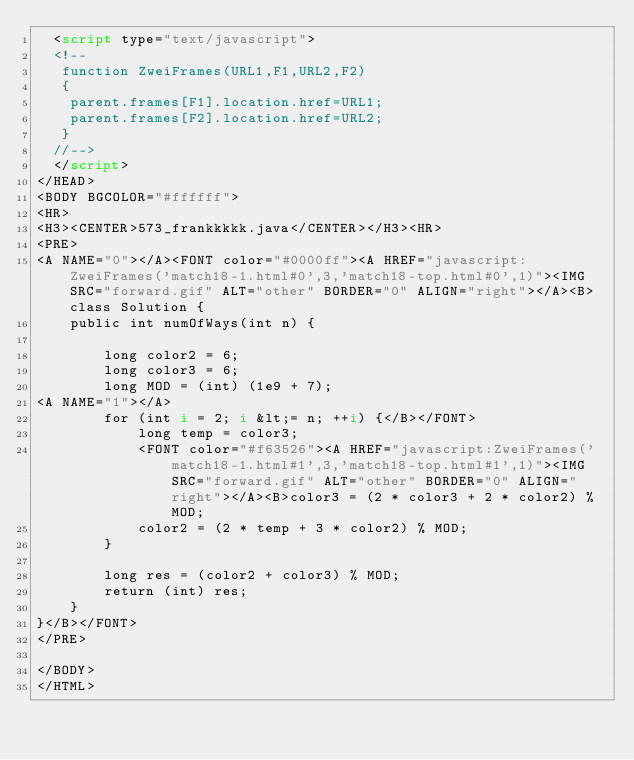<code> <loc_0><loc_0><loc_500><loc_500><_HTML_>  <script type="text/javascript">
  <!--
   function ZweiFrames(URL1,F1,URL2,F2)
   {
    parent.frames[F1].location.href=URL1;
    parent.frames[F2].location.href=URL2;
   }
  //-->
  </script>
</HEAD>
<BODY BGCOLOR="#ffffff">
<HR>
<H3><CENTER>573_frankkkkk.java</CENTER></H3><HR>
<PRE>
<A NAME="0"></A><FONT color="#0000ff"><A HREF="javascript:ZweiFrames('match18-1.html#0',3,'match18-top.html#0',1)"><IMG SRC="forward.gif" ALT="other" BORDER="0" ALIGN="right"></A><B>class Solution {
    public int numOfWays(int n) {
        
        long color2 = 6;
        long color3 = 6;
        long MOD = (int) (1e9 + 7);
<A NAME="1"></A>        
        for (int i = 2; i &lt;= n; ++i) {</B></FONT>
            long temp = color3;
            <FONT color="#f63526"><A HREF="javascript:ZweiFrames('match18-1.html#1',3,'match18-top.html#1',1)"><IMG SRC="forward.gif" ALT="other" BORDER="0" ALIGN="right"></A><B>color3 = (2 * color3 + 2 * color2) % MOD;
            color2 = (2 * temp + 3 * color2) % MOD;
        }
        
        long res = (color2 + color3) % MOD;
        return (int) res;
    }
}</B></FONT>
</PRE>

</BODY>
</HTML>
</code> 